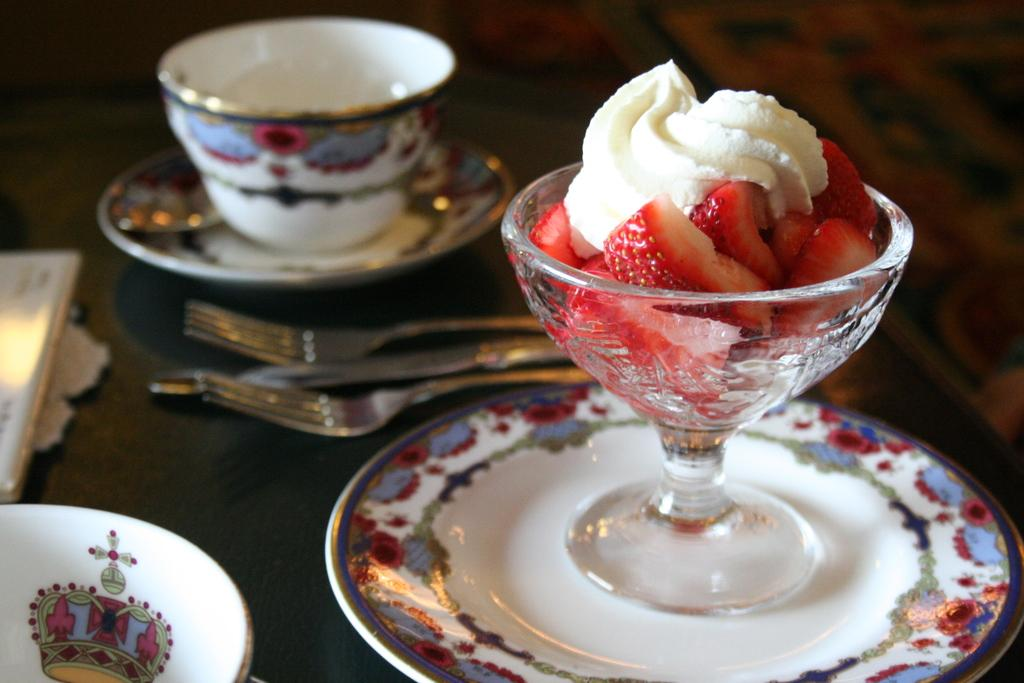What type of dishware can be seen in the image? There are plates and a cup in the image. What is in the glass that is visible in the image? There is a glass with fruits and cream in the image. What utensils are present in the image? There are forks and a knife in the image. Where are the objects located in the image? The objects are on a platform in the image. How would you describe the background of the image? The background of the image is blurry. Who is the creator of the comfort in the image? There is no reference to comfort or a creator in the image; it features plates, a cup, a glass with fruits and cream, forks, a knife, and objects on a platform with a blurry background. 